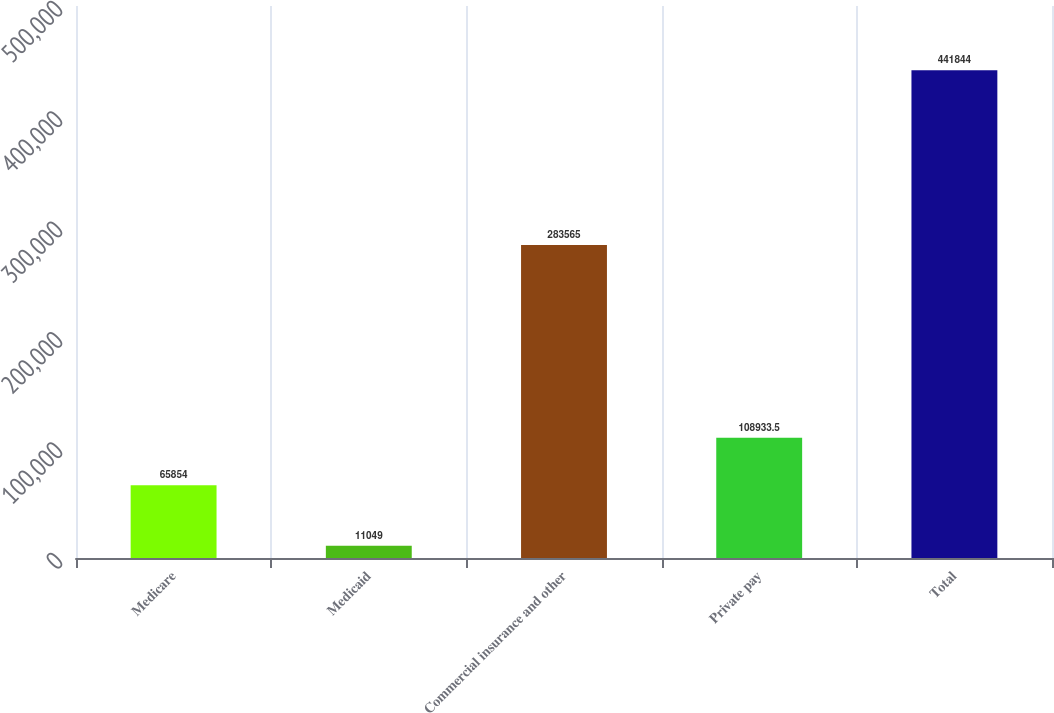Convert chart to OTSL. <chart><loc_0><loc_0><loc_500><loc_500><bar_chart><fcel>Medicare<fcel>Medicaid<fcel>Commercial insurance and other<fcel>Private pay<fcel>Total<nl><fcel>65854<fcel>11049<fcel>283565<fcel>108934<fcel>441844<nl></chart> 